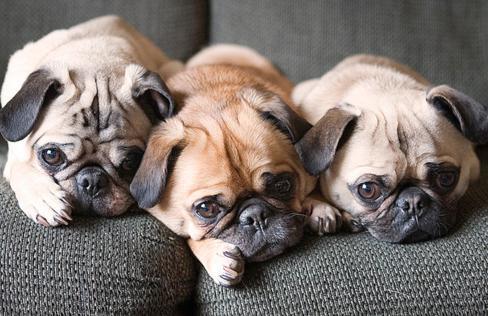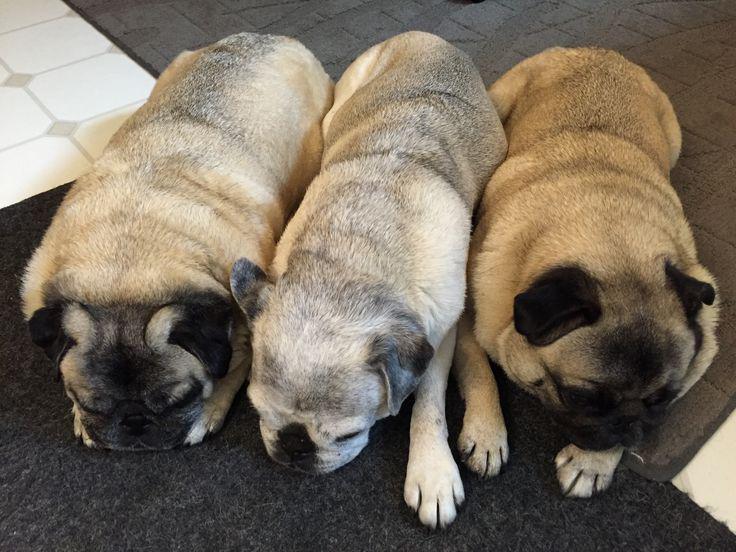The first image is the image on the left, the second image is the image on the right. Analyze the images presented: Is the assertion "The dogs in the image on the right are wearing winter coats." valid? Answer yes or no. No. The first image is the image on the left, the second image is the image on the right. Analyze the images presented: Is the assertion "Three pugs are posed in a row wearing outfits with fur collars." valid? Answer yes or no. No. 